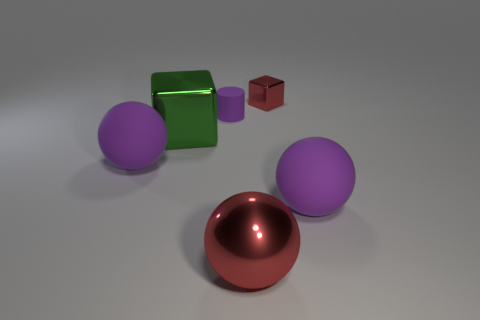Does the large object that is right of the big red metallic thing have the same material as the cylinder?
Your response must be concise. Yes. What is the thing that is to the right of the large red thing and behind the big green thing made of?
Provide a succinct answer. Metal. The thing that is the same color as the small shiny block is what size?
Keep it short and to the point. Large. There is a purple ball in front of the large ball that is to the left of the tiny purple object; what is it made of?
Keep it short and to the point. Rubber. What size is the red thing that is behind the purple thing on the right side of the shiny object to the right of the large metallic ball?
Your answer should be compact. Small. How many big blocks have the same material as the big red thing?
Your answer should be compact. 1. There is a large rubber ball on the right side of the large metallic thing that is on the right side of the small purple thing; what is its color?
Your answer should be compact. Purple. How many objects are large green objects or purple matte balls that are right of the tiny metal cube?
Offer a terse response. 2. Is there a rubber sphere that has the same color as the tiny matte cylinder?
Ensure brevity in your answer.  Yes. How many red things are small things or cylinders?
Give a very brief answer. 1. 